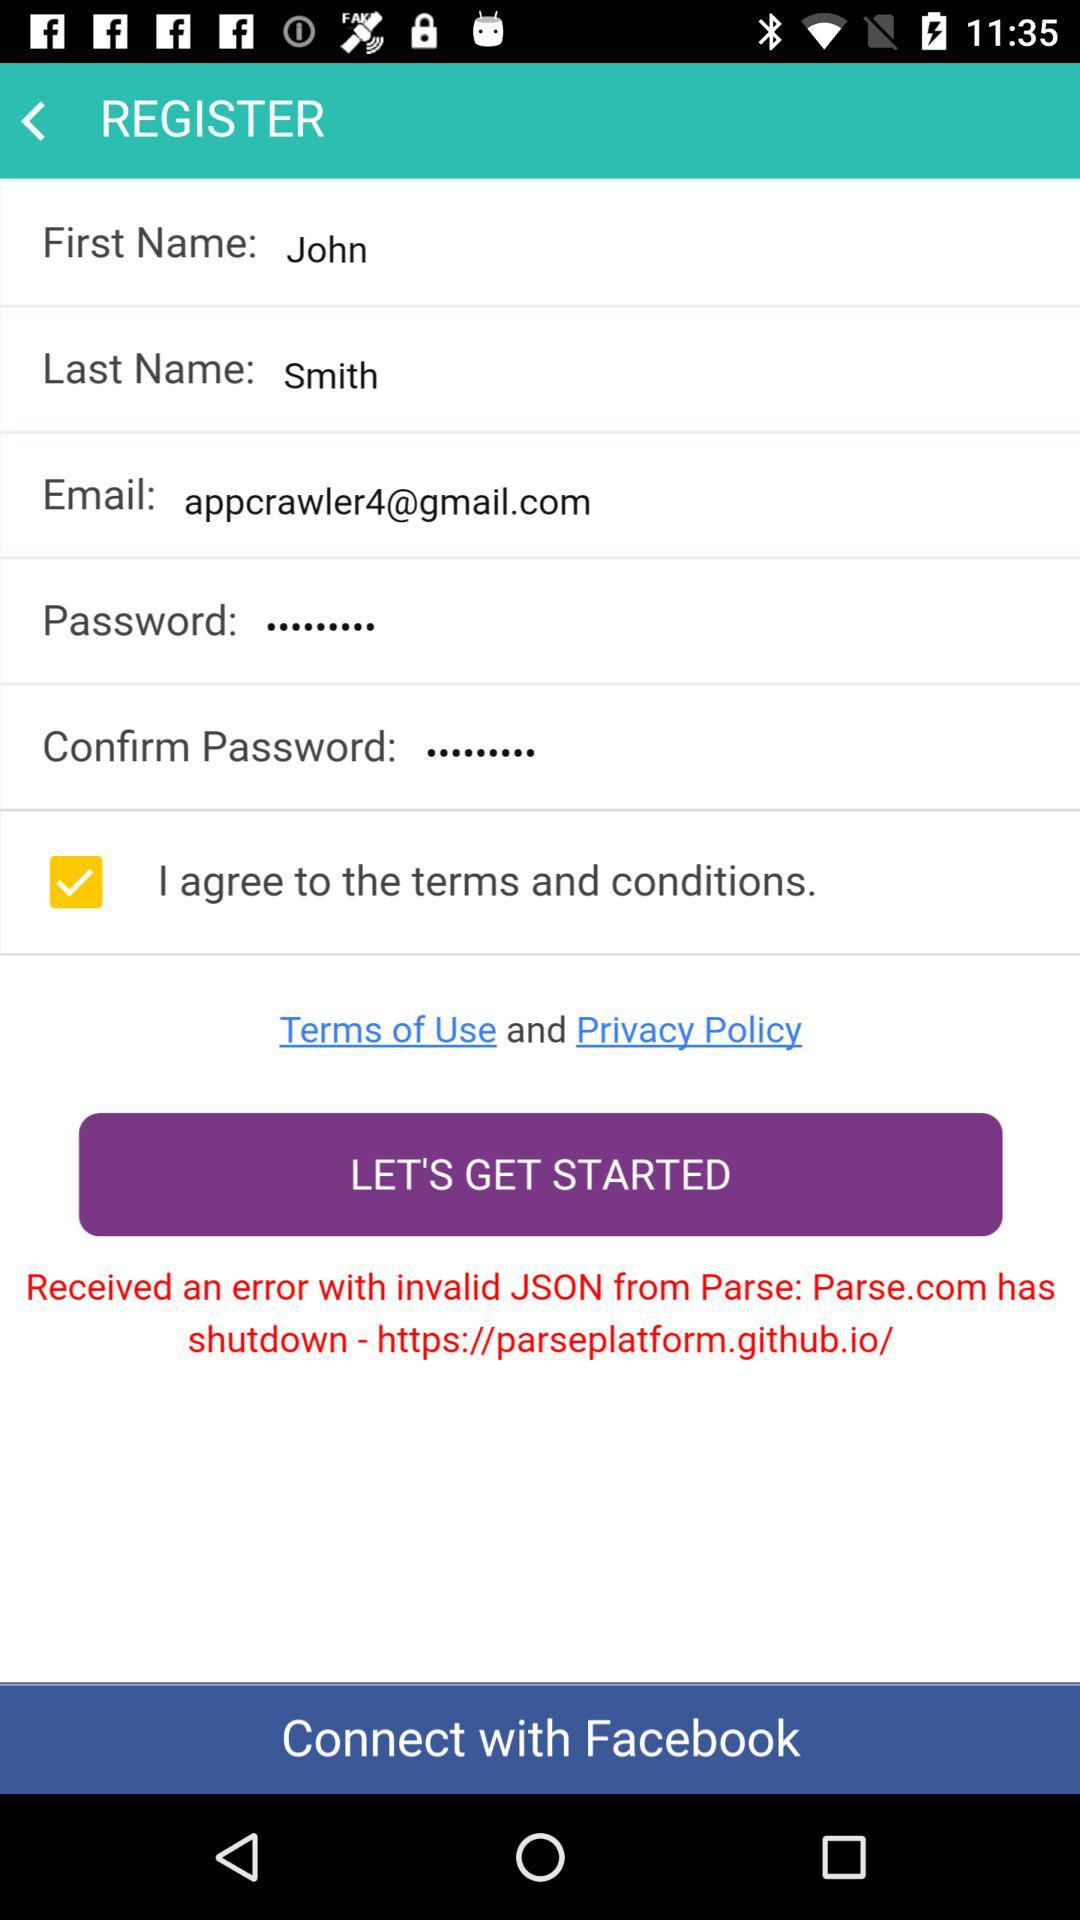How many inputs are there on this form?
Answer the question using a single word or phrase. 5 